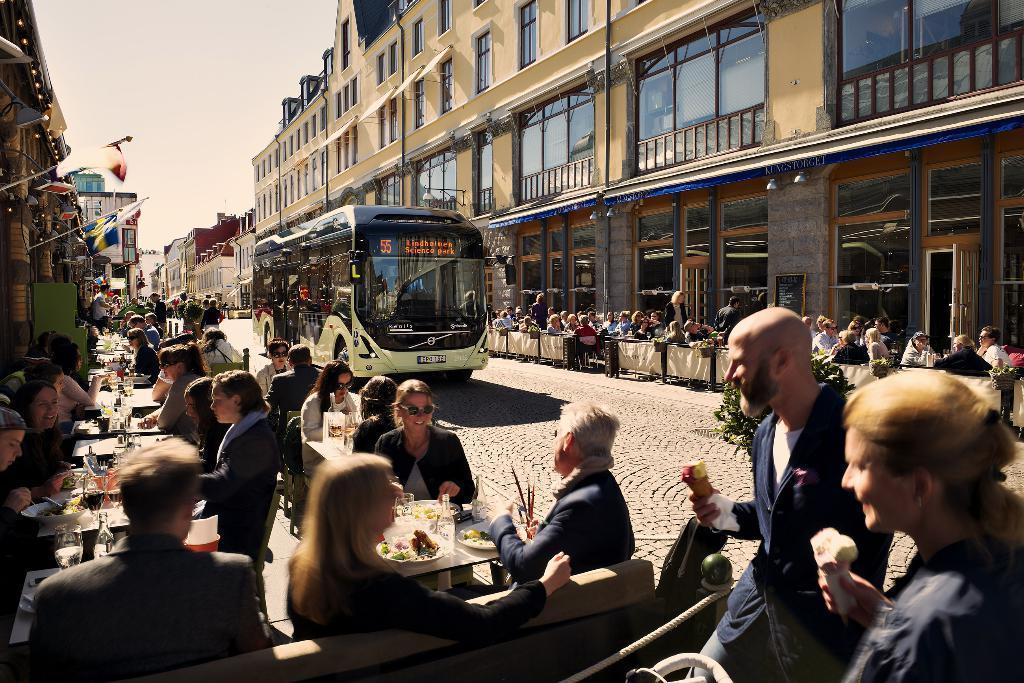Please provide a concise description of this image. As we can see in the image there are group of people here and there, bus, flags, buildings, sky, chairs and tables. On tables there are bottles, glasses and dishes. 